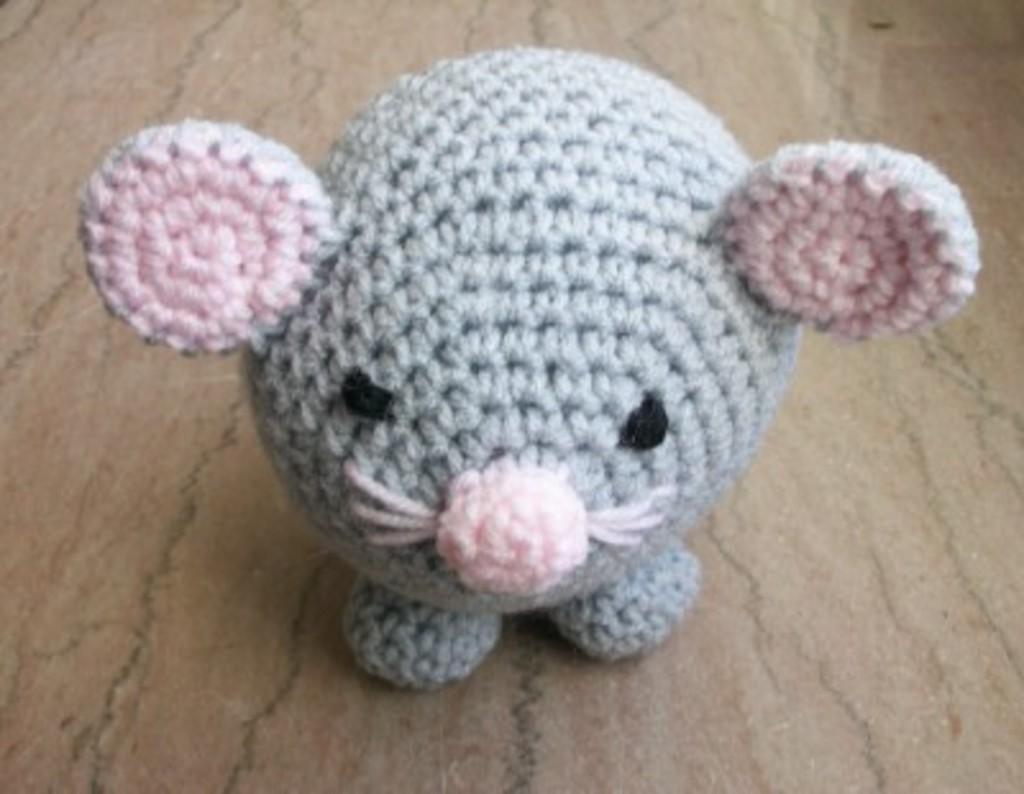How would you summarize this image in a sentence or two? In this picture we can see a doll placed on the marble platform. 